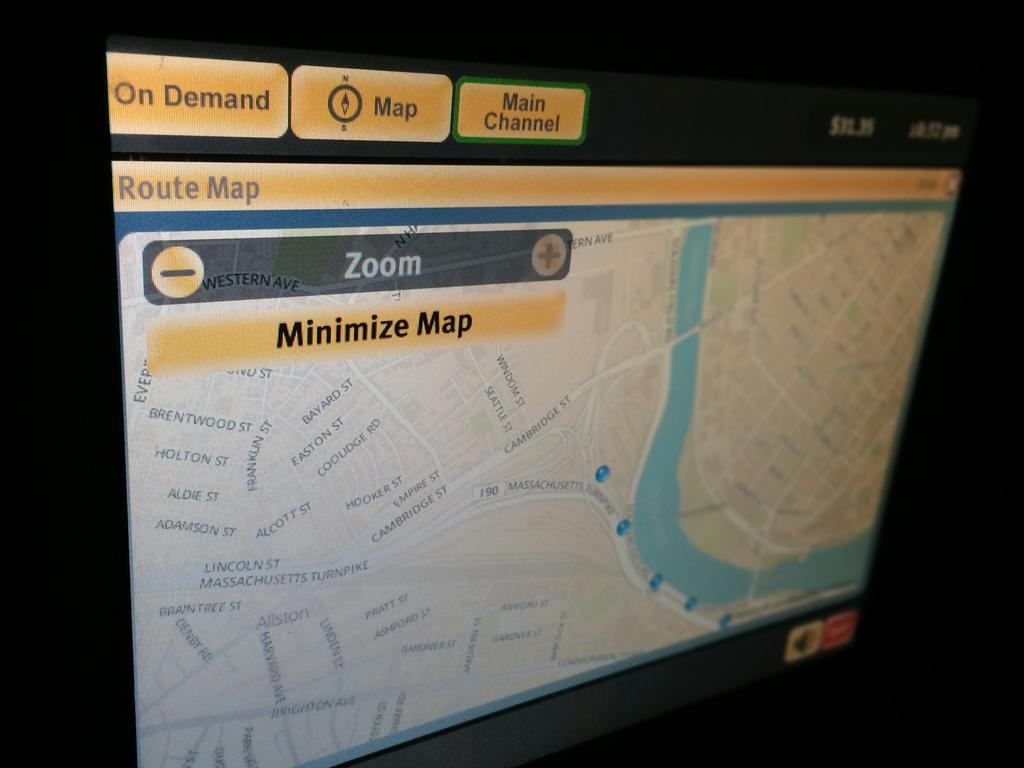<image>
Share a concise interpretation of the image provided. A screen showing a map that gives the option to minimise the map. 